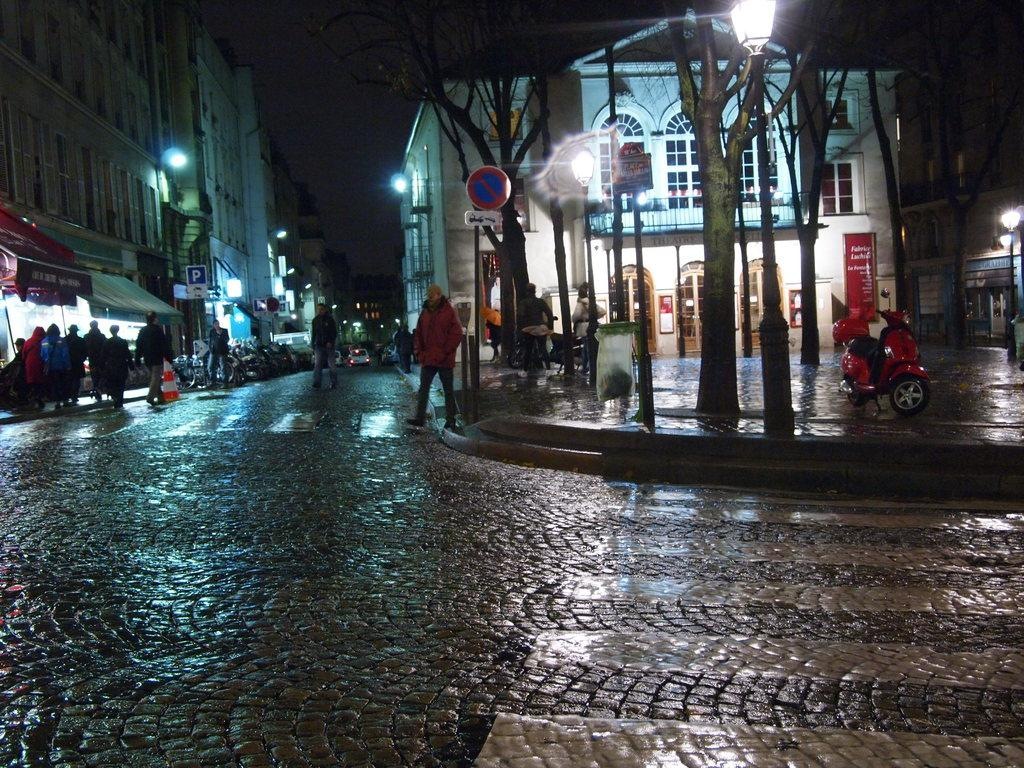Who or what can be seen in the image? There are people in the image. What type of infrastructure is present in the image? There are street lights and vehicles in the image. What is the main feature of the image? There is a road in the image. What can be seen in the background of the image? There are buildings and the sky visible in the background of the image. Where is the bun located in the image? There is no bun present in the image. What fact can be learned about the dock from the image? There is no dock present in the image, so no fact about a dock can be learned from it. 